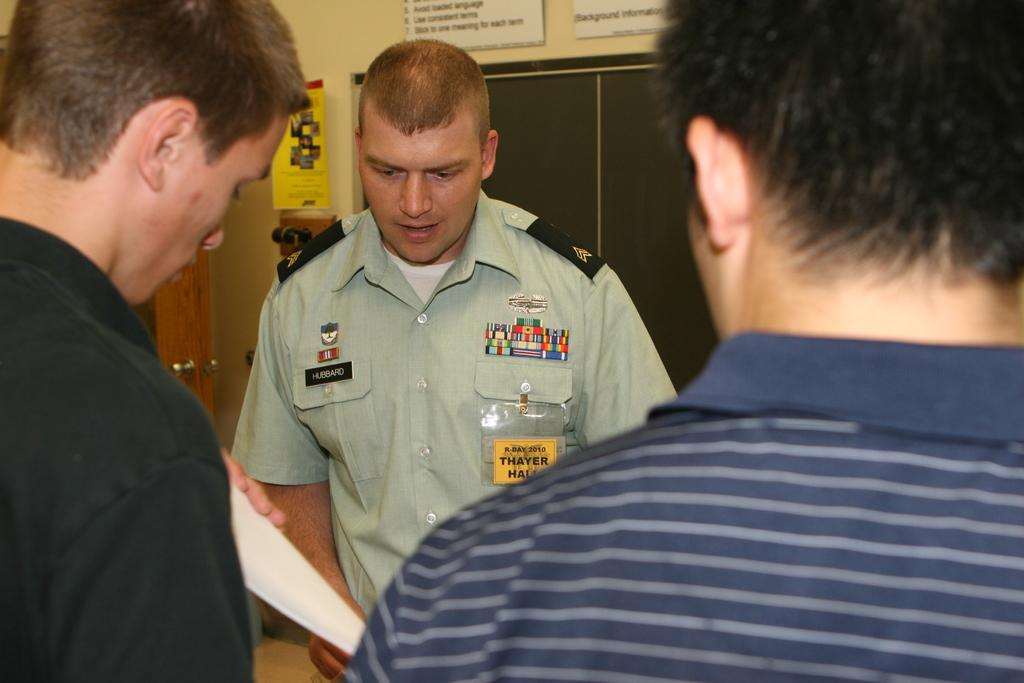<image>
Create a compact narrative representing the image presented. A young military man named Hubbard is standing with two civilians. 